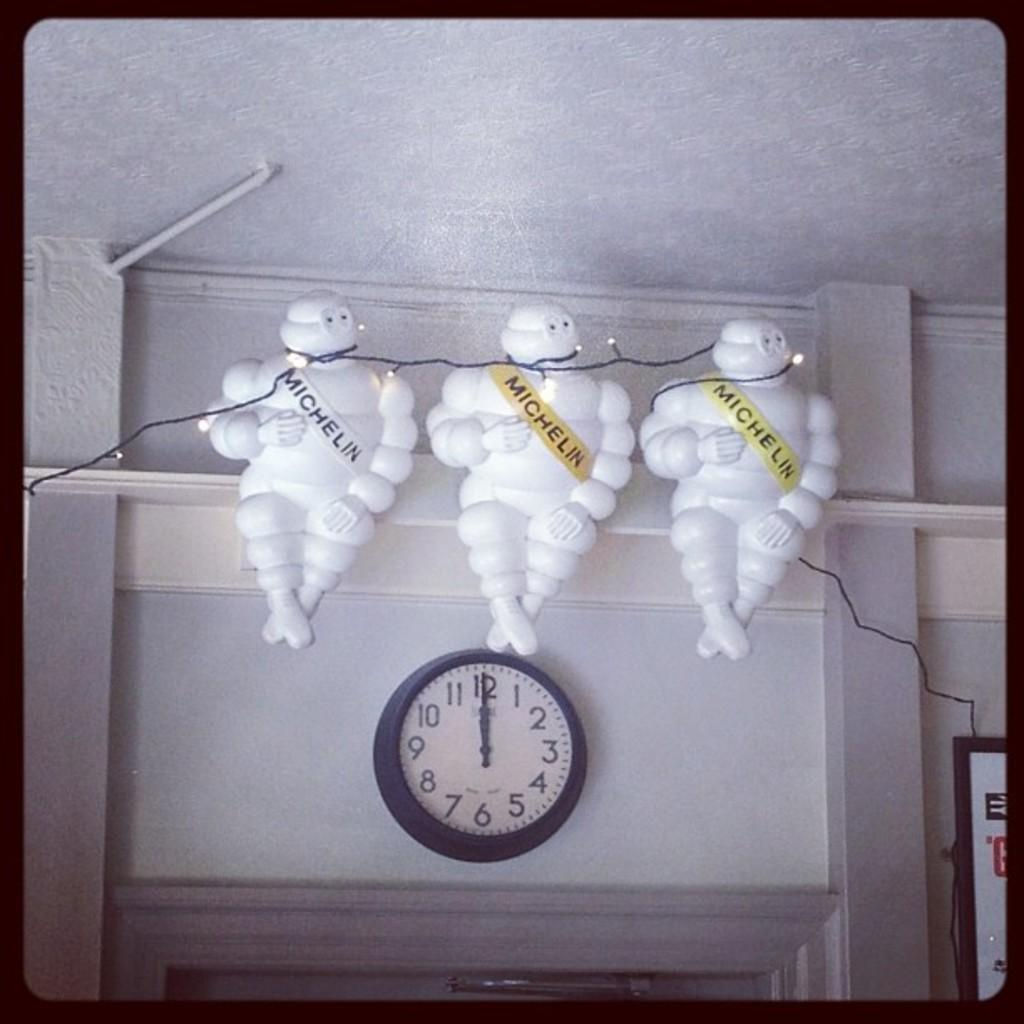Provide a one-sentence caption for the provided image. the number 12 that is on a clock. 